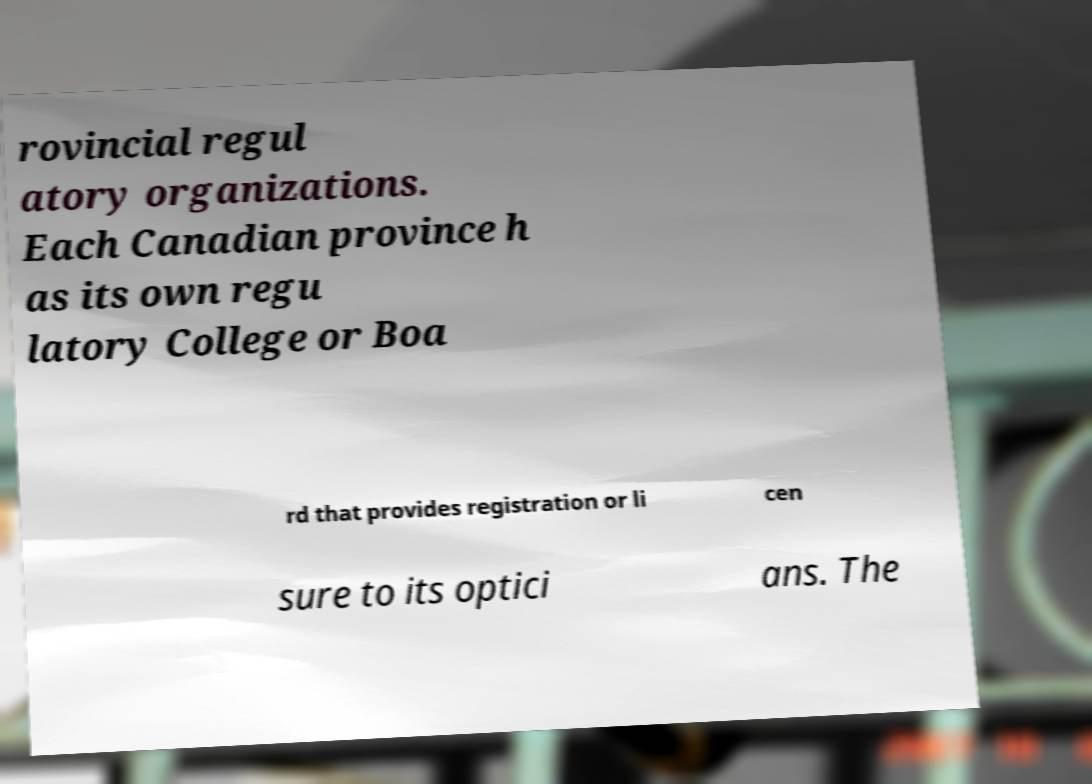Can you accurately transcribe the text from the provided image for me? rovincial regul atory organizations. Each Canadian province h as its own regu latory College or Boa rd that provides registration or li cen sure to its optici ans. The 